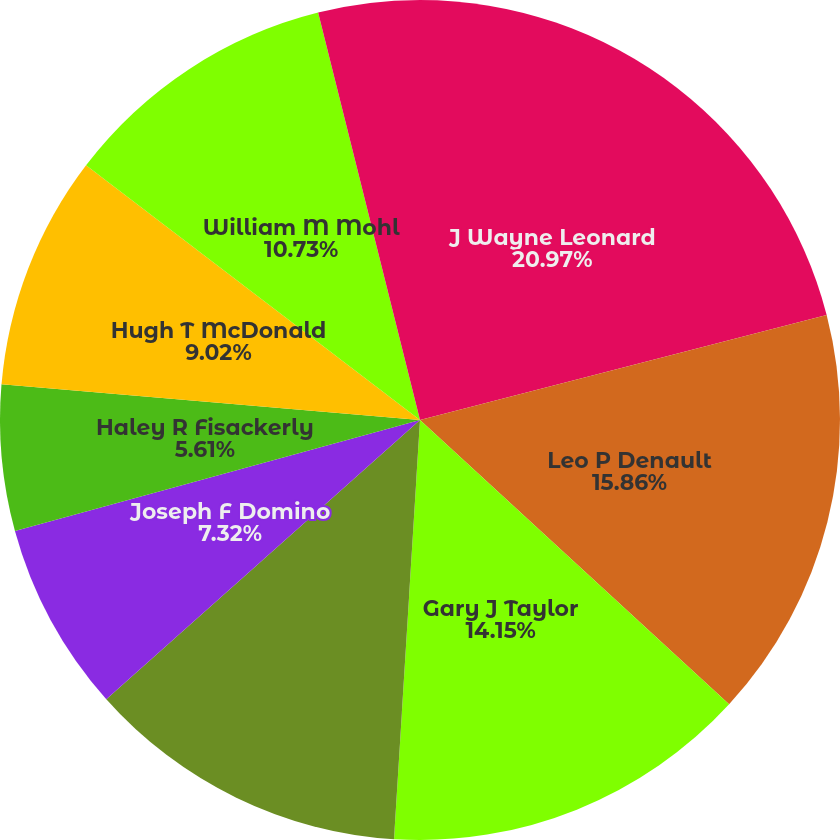Convert chart to OTSL. <chart><loc_0><loc_0><loc_500><loc_500><pie_chart><fcel>J Wayne Leonard<fcel>Leo P Denault<fcel>Gary J Taylor<fcel>Theodore H Bunting Jr<fcel>Joseph F Domino<fcel>Haley R Fisackerly<fcel>Hugh T McDonald<fcel>William M Mohl<fcel>Charles L Rice Jr<nl><fcel>20.98%<fcel>15.86%<fcel>14.15%<fcel>12.44%<fcel>7.32%<fcel>5.61%<fcel>9.02%<fcel>10.73%<fcel>3.9%<nl></chart> 